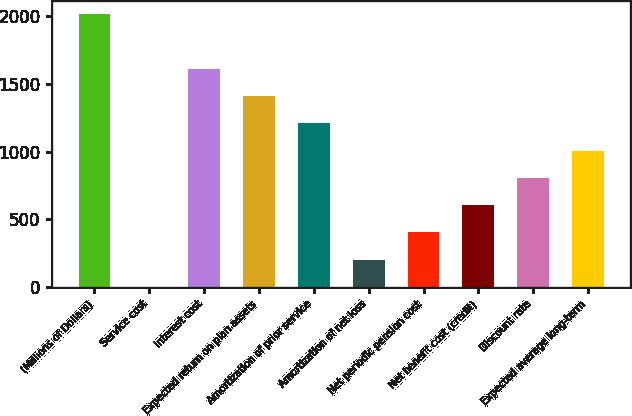Convert chart. <chart><loc_0><loc_0><loc_500><loc_500><bar_chart><fcel>(Millions of Dollars)<fcel>Service cost<fcel>Interest cost<fcel>Expected return on plan assets<fcel>Amortization of prior service<fcel>Amortization of net loss<fcel>Net periodic pension cost<fcel>Net benefit cost (credit)<fcel>Discount rate<fcel>Expected average long-term<nl><fcel>2016<fcel>2<fcel>1613.2<fcel>1411.8<fcel>1210.4<fcel>203.4<fcel>404.8<fcel>606.2<fcel>807.6<fcel>1009<nl></chart> 